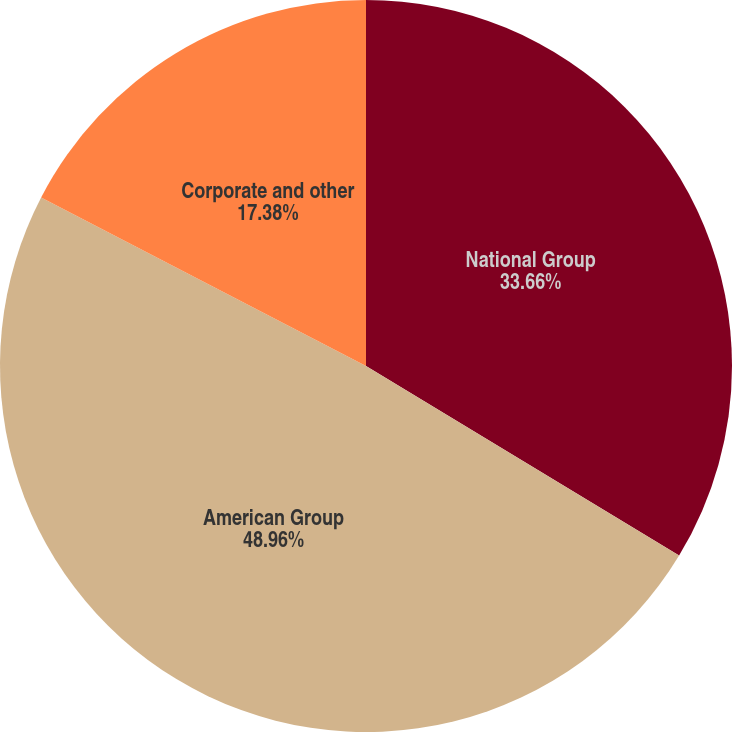<chart> <loc_0><loc_0><loc_500><loc_500><pie_chart><fcel>National Group<fcel>American Group<fcel>Corporate and other<nl><fcel>33.66%<fcel>48.95%<fcel>17.38%<nl></chart> 